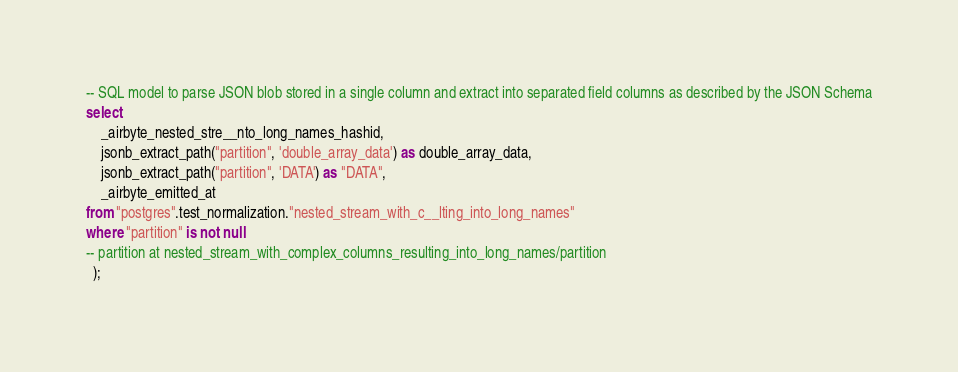<code> <loc_0><loc_0><loc_500><loc_500><_SQL_>-- SQL model to parse JSON blob stored in a single column and extract into separated field columns as described by the JSON Schema
select
    _airbyte_nested_stre__nto_long_names_hashid,
    jsonb_extract_path("partition", 'double_array_data') as double_array_data,
    jsonb_extract_path("partition", 'DATA') as "DATA",
    _airbyte_emitted_at
from "postgres".test_normalization."nested_stream_with_c__lting_into_long_names"
where "partition" is not null
-- partition at nested_stream_with_complex_columns_resulting_into_long_names/partition
  );
</code> 